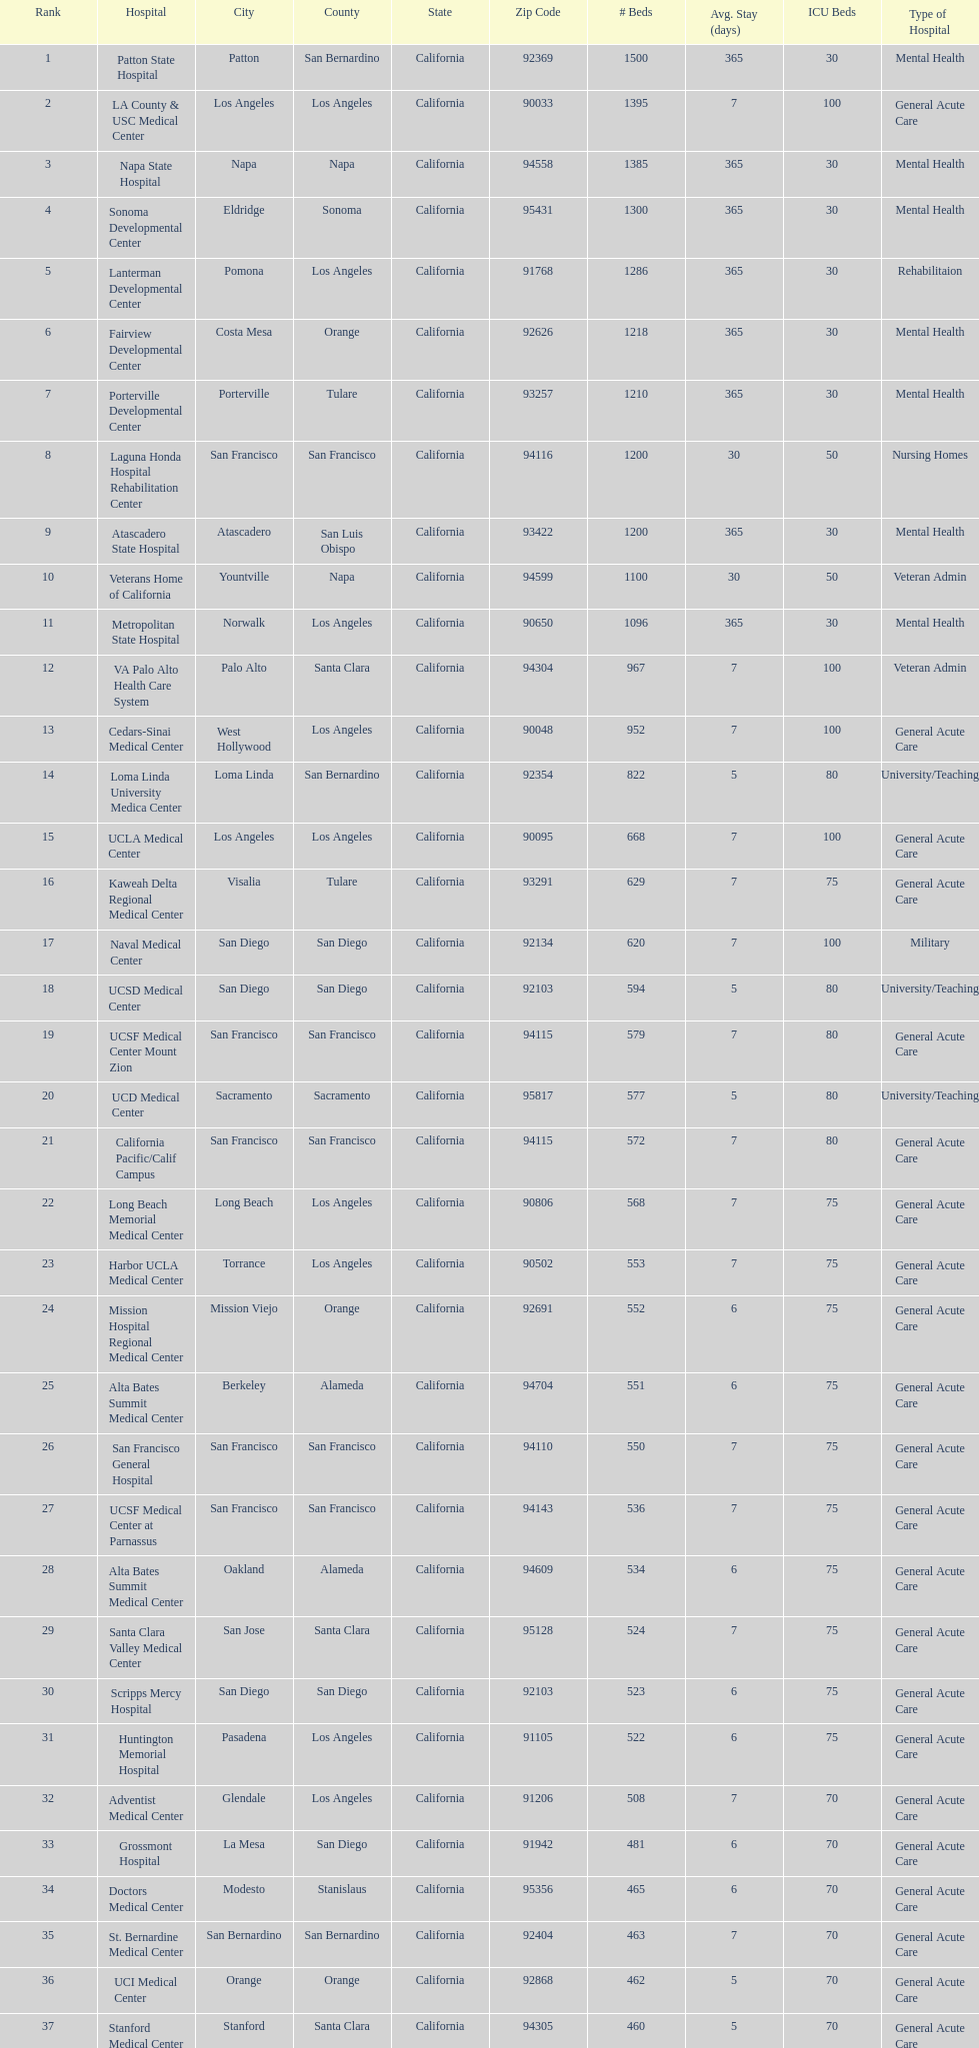Does patton state hospital in the city of patton in san bernardino county have more mental health hospital beds than atascadero state hospital in atascadero, san luis obispo county? Yes. 